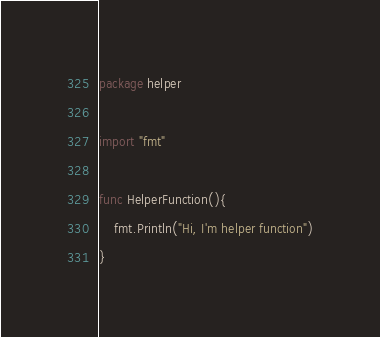<code> <loc_0><loc_0><loc_500><loc_500><_Go_>package helper

import "fmt"

func HelperFunction(){
	fmt.Println("Hi, I'm helper function")
}</code> 